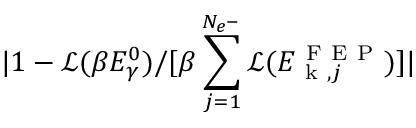<formula> <loc_0><loc_0><loc_500><loc_500>| 1 - \mathcal { L } ( \beta E _ { \gamma } ^ { 0 } ) / [ \beta \sum _ { j = 1 } ^ { N _ { e ^ { - } } } \mathcal { L } ( E _ { k , j } ^ { F E P } ) ] |</formula> 